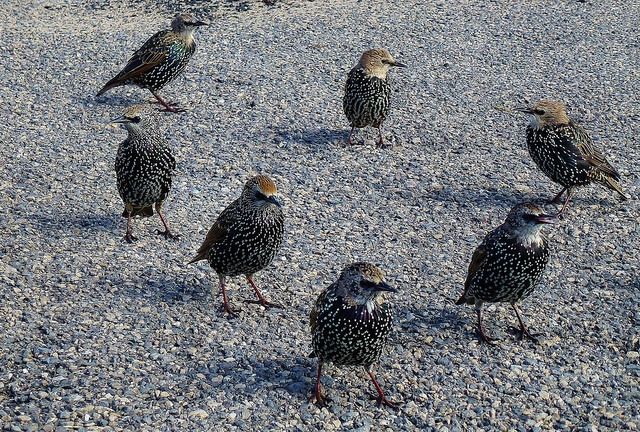Describe the objects in this image and their specific colors. I can see bird in gray, black, and darkgray tones, bird in gray, black, and darkgray tones, bird in gray, black, and darkgray tones, bird in gray, black, darkgray, and maroon tones, and bird in gray, black, darkgray, and lightgray tones in this image. 